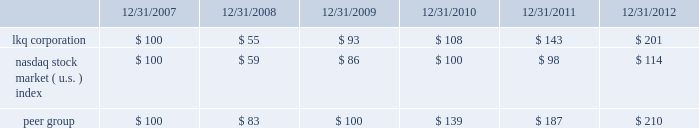Comparison of cumulative return among lkq corporation , the nasdaq stock market ( u.s. ) index and the peer group .
This stock performance information is "furnished" and shall not be deemed to be "soliciting material" or subject to rule 14a , shall not be deemed "filed" for purposes of section 18 of the securities exchange act of 1934 or otherwise subject to the liabilities of that section , and shall not be deemed incorporated by reference in any filing under the securities act of 1933 or the securities exchange act of 1934 , whether made before or after the date of this report and irrespective of any general incorporation by reference language in any such filing , except to the extent that it specifically incorporates the information by reference .
Information about our common stock that may be issued under our equity compensation plans as of december 31 , 2012 included in part iii , item 12 of this annual report on form 10-k is incorporated herein by reference. .
What was the percentage of cumulative return for lkq corporation for the five years ended 12/31/2012? 
Computations: ((201 - 100) / 100)
Answer: 1.01. 